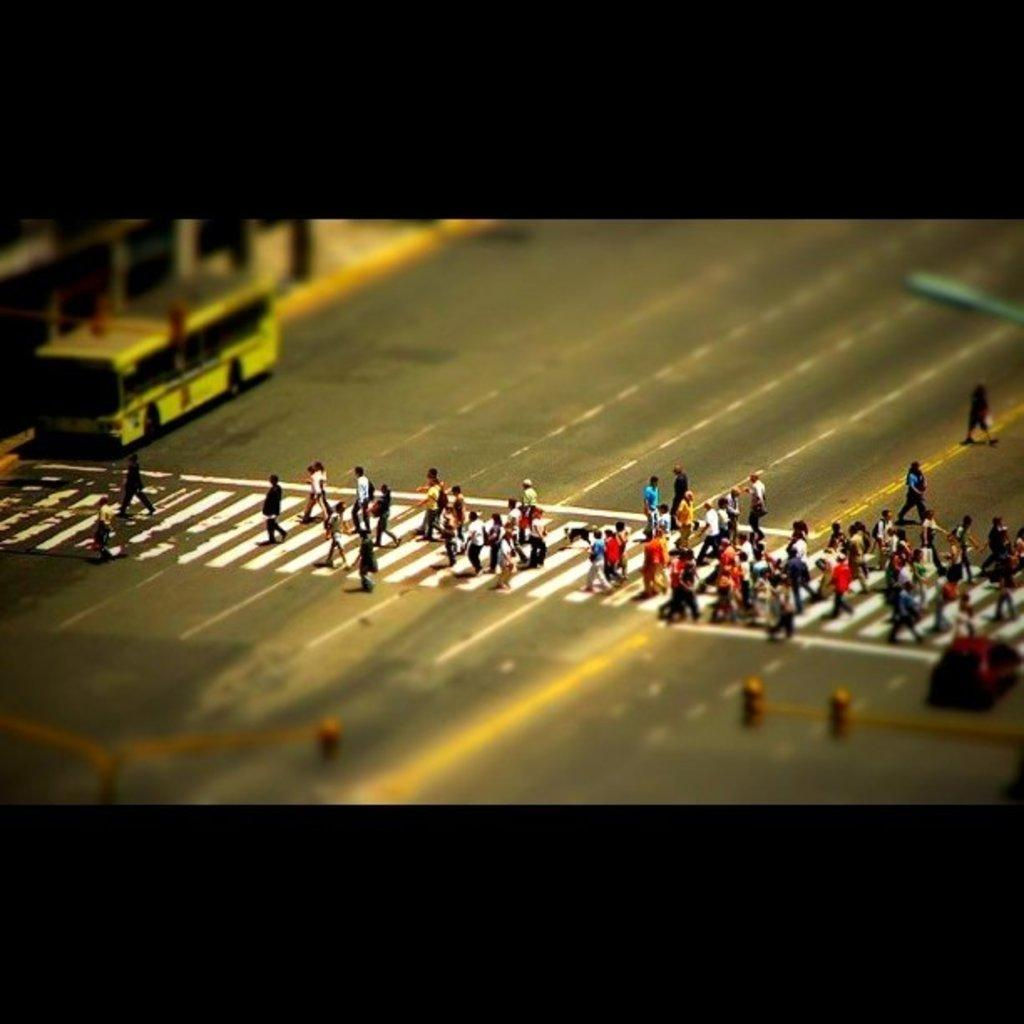What is the main feature of the image? There is a road in the image. What are the people in the image doing? People are walking on the road. What mode of transportation can be seen on the road? There is a bus on the road. What helps regulate the flow of traffic in the image? Traffic lights are visible in the image. What other vehicle is present in the image? There is a car on the right side of the image. What type of hair can be seen on the potato in the image? There is no potato present in the image, and therefore no hair to be observed. Who is guiding the people walking on the road in the image? The image does not show anyone guiding the people walking on the road. 